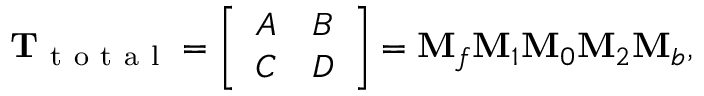Convert formula to latex. <formula><loc_0><loc_0><loc_500><loc_500>T _ { t o t a l } = \left [ \begin{array} { l l } { A } & { B } \\ { C } & { D } \end{array} \right ] = M _ { f } M _ { 1 } M _ { 0 } M _ { 2 } M _ { b } ,</formula> 